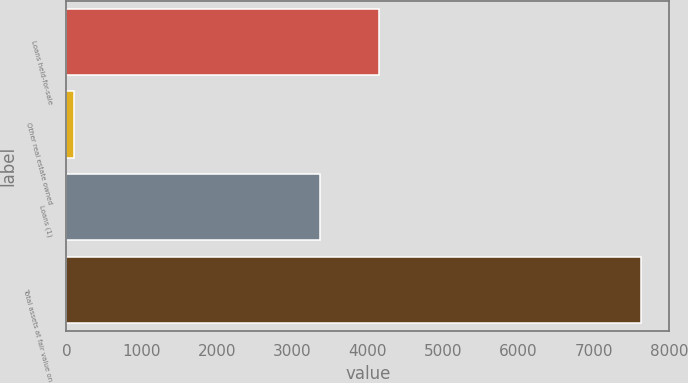<chart> <loc_0><loc_0><loc_500><loc_500><bar_chart><fcel>Loans held-for-sale<fcel>Other real estate owned<fcel>Loans (1)<fcel>Total assets at fair value on<nl><fcel>4152<fcel>102<fcel>3367<fcel>7621<nl></chart> 